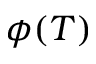Convert formula to latex. <formula><loc_0><loc_0><loc_500><loc_500>\phi ( T )</formula> 